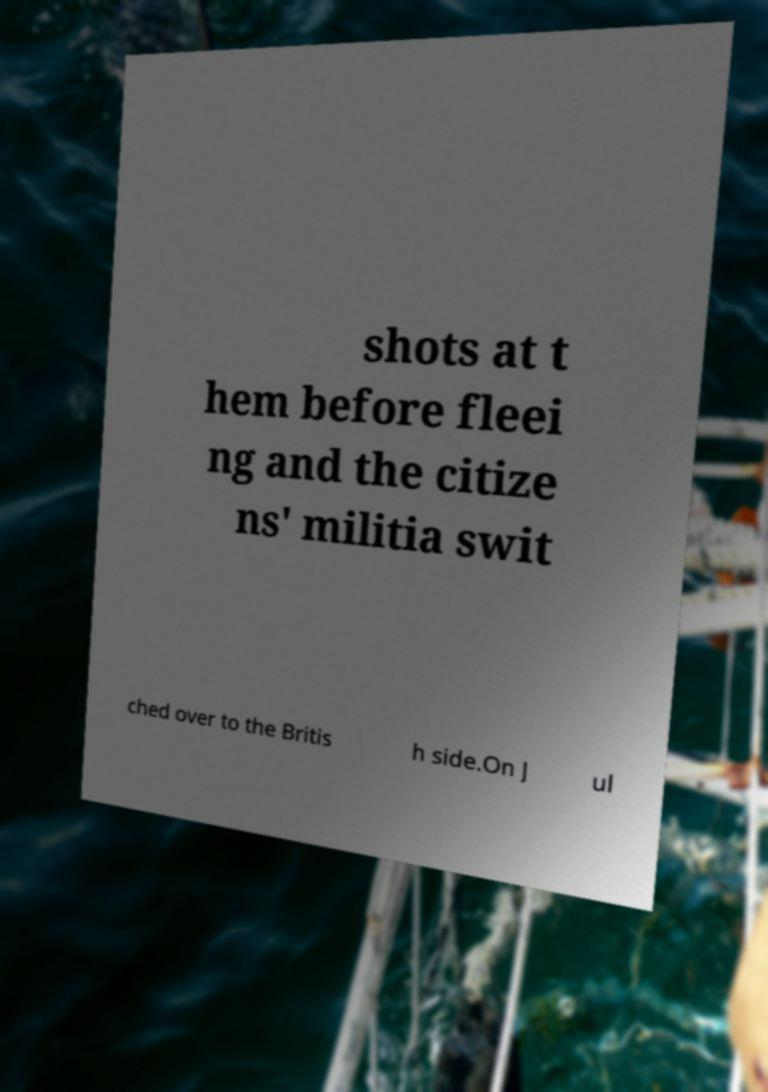Could you assist in decoding the text presented in this image and type it out clearly? shots at t hem before fleei ng and the citize ns' militia swit ched over to the Britis h side.On J ul 